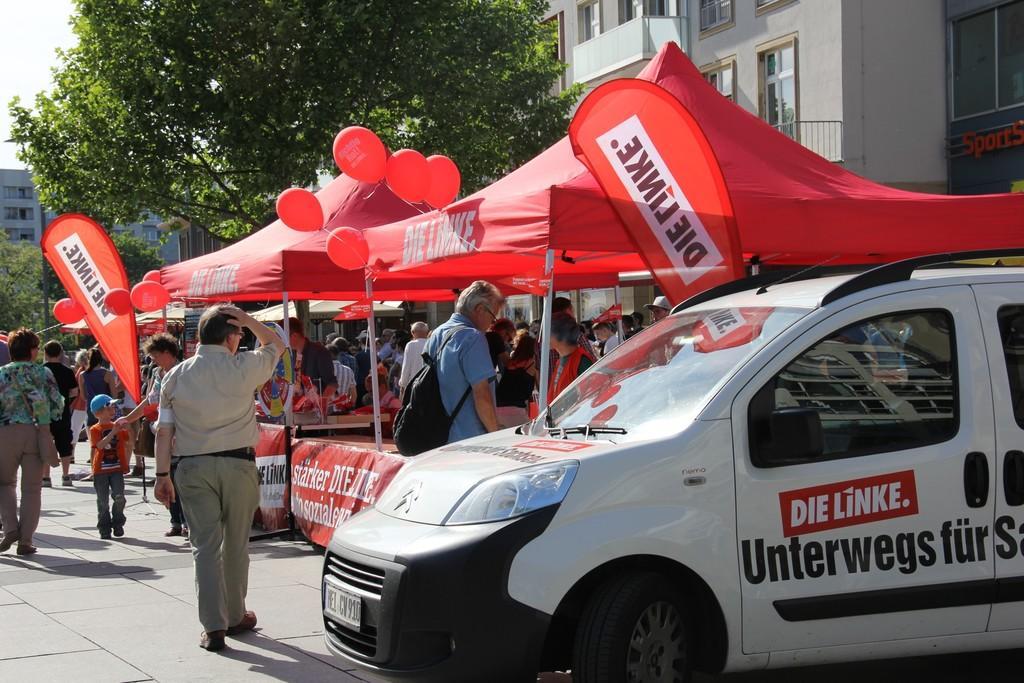Describe this image in one or two sentences. In this image there are few stalls decorated with balloons, in front of them there are so many people standing and few are walking on the road. On the right side of the image there is a vehicle parked. In the background there are buildings and trees. 